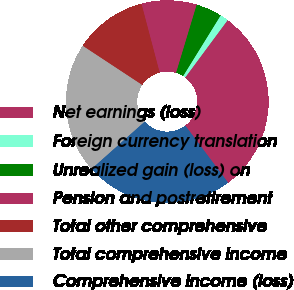Convert chart. <chart><loc_0><loc_0><loc_500><loc_500><pie_chart><fcel>Net earnings (loss)<fcel>Foreign currency translation<fcel>Unrealized gain (loss) on<fcel>Pension and postretirement<fcel>Total other comprehensive<fcel>Total comprehensive income<fcel>Comprehensive income (loss)<nl><fcel>29.62%<fcel>1.32%<fcel>4.15%<fcel>8.78%<fcel>11.62%<fcel>20.84%<fcel>23.67%<nl></chart> 